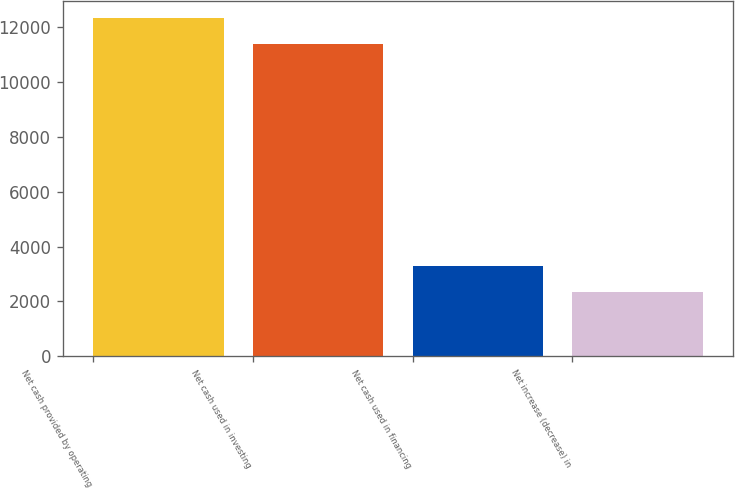Convert chart. <chart><loc_0><loc_0><loc_500><loc_500><bar_chart><fcel>Net cash provided by operating<fcel>Net cash used in investing<fcel>Net cash used in financing<fcel>Net increase (decrease) in<nl><fcel>12316.2<fcel>11359<fcel>3307.2<fcel>2350<nl></chart> 